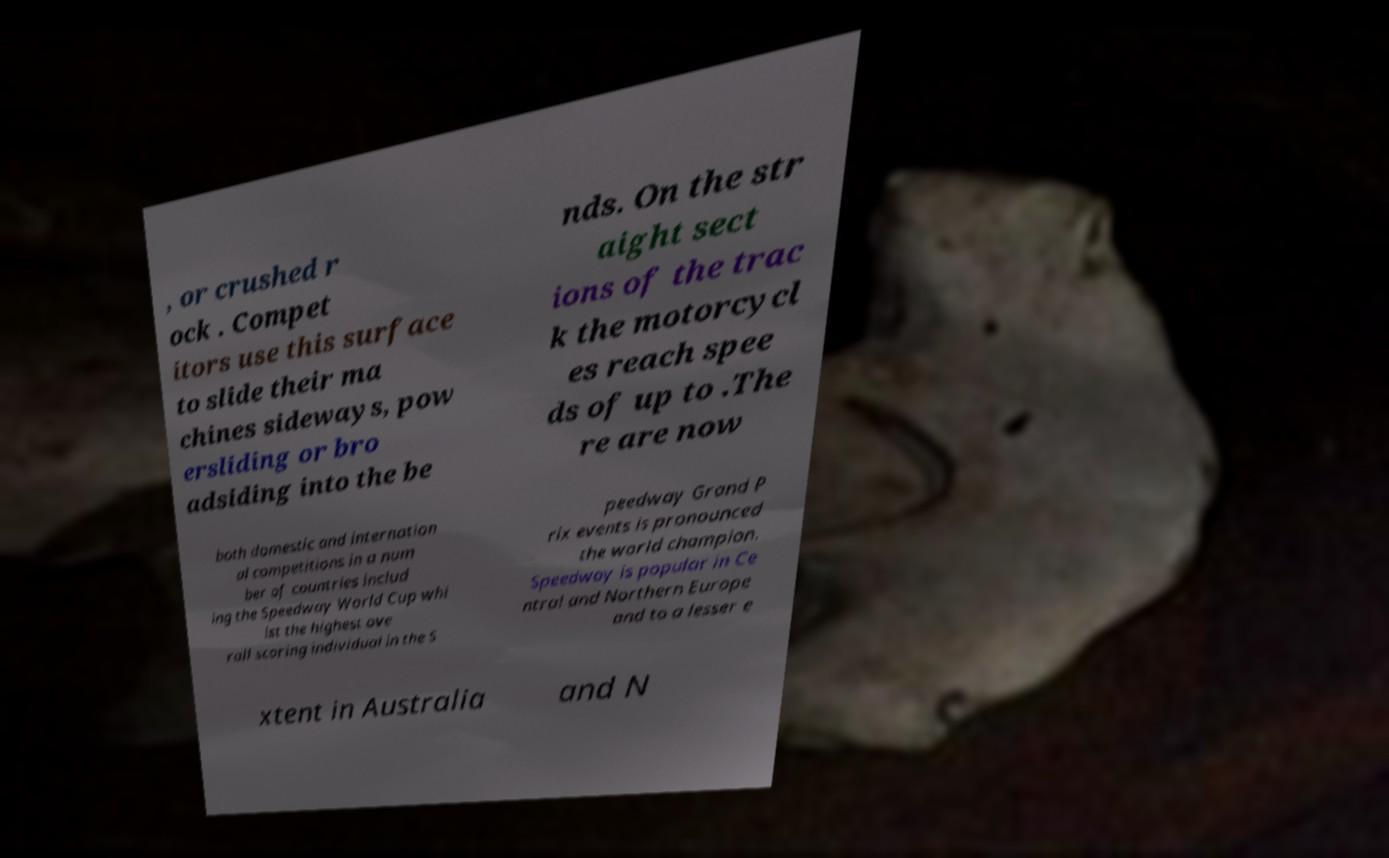I need the written content from this picture converted into text. Can you do that? , or crushed r ock . Compet itors use this surface to slide their ma chines sideways, pow ersliding or bro adsiding into the be nds. On the str aight sect ions of the trac k the motorcycl es reach spee ds of up to .The re are now both domestic and internation al competitions in a num ber of countries includ ing the Speedway World Cup whi lst the highest ove rall scoring individual in the S peedway Grand P rix events is pronounced the world champion. Speedway is popular in Ce ntral and Northern Europe and to a lesser e xtent in Australia and N 